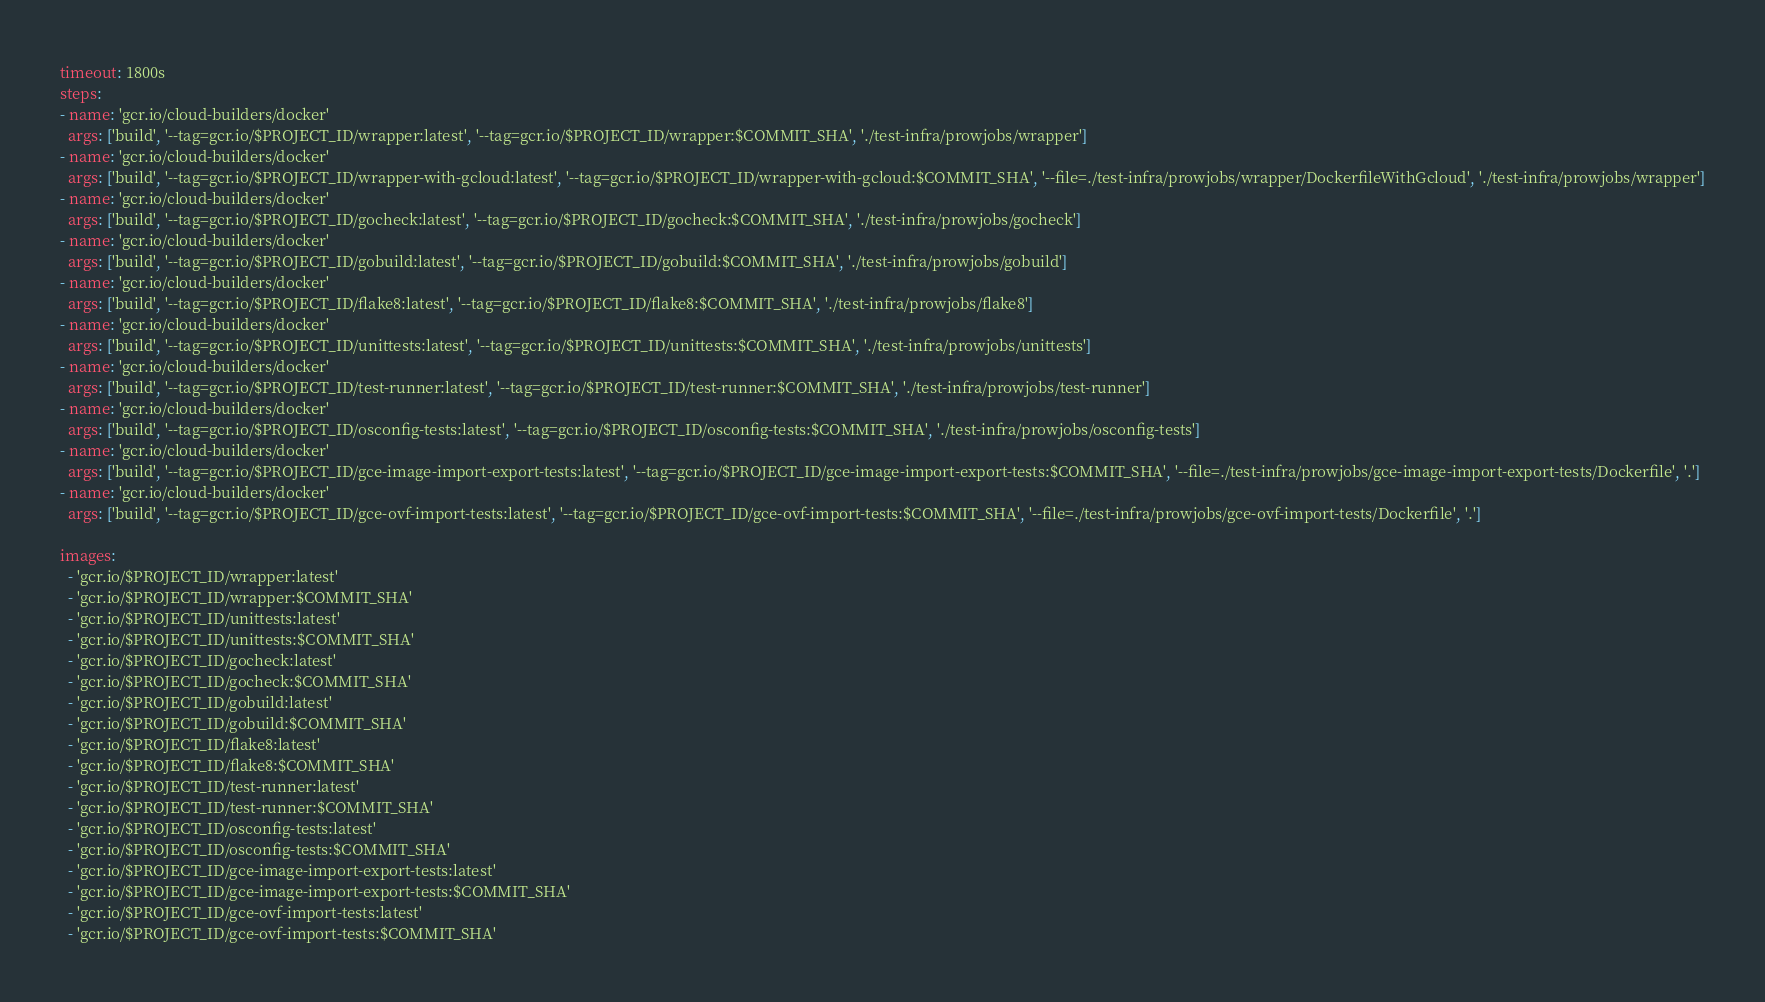Convert code to text. <code><loc_0><loc_0><loc_500><loc_500><_YAML_>timeout: 1800s
steps:
- name: 'gcr.io/cloud-builders/docker'
  args: ['build', '--tag=gcr.io/$PROJECT_ID/wrapper:latest', '--tag=gcr.io/$PROJECT_ID/wrapper:$COMMIT_SHA', './test-infra/prowjobs/wrapper']
- name: 'gcr.io/cloud-builders/docker'
  args: ['build', '--tag=gcr.io/$PROJECT_ID/wrapper-with-gcloud:latest', '--tag=gcr.io/$PROJECT_ID/wrapper-with-gcloud:$COMMIT_SHA', '--file=./test-infra/prowjobs/wrapper/DockerfileWithGcloud', './test-infra/prowjobs/wrapper']
- name: 'gcr.io/cloud-builders/docker'
  args: ['build', '--tag=gcr.io/$PROJECT_ID/gocheck:latest', '--tag=gcr.io/$PROJECT_ID/gocheck:$COMMIT_SHA', './test-infra/prowjobs/gocheck']
- name: 'gcr.io/cloud-builders/docker'
  args: ['build', '--tag=gcr.io/$PROJECT_ID/gobuild:latest', '--tag=gcr.io/$PROJECT_ID/gobuild:$COMMIT_SHA', './test-infra/prowjobs/gobuild']
- name: 'gcr.io/cloud-builders/docker'
  args: ['build', '--tag=gcr.io/$PROJECT_ID/flake8:latest', '--tag=gcr.io/$PROJECT_ID/flake8:$COMMIT_SHA', './test-infra/prowjobs/flake8']
- name: 'gcr.io/cloud-builders/docker'
  args: ['build', '--tag=gcr.io/$PROJECT_ID/unittests:latest', '--tag=gcr.io/$PROJECT_ID/unittests:$COMMIT_SHA', './test-infra/prowjobs/unittests']
- name: 'gcr.io/cloud-builders/docker'
  args: ['build', '--tag=gcr.io/$PROJECT_ID/test-runner:latest', '--tag=gcr.io/$PROJECT_ID/test-runner:$COMMIT_SHA', './test-infra/prowjobs/test-runner']
- name: 'gcr.io/cloud-builders/docker'
  args: ['build', '--tag=gcr.io/$PROJECT_ID/osconfig-tests:latest', '--tag=gcr.io/$PROJECT_ID/osconfig-tests:$COMMIT_SHA', './test-infra/prowjobs/osconfig-tests']
- name: 'gcr.io/cloud-builders/docker'
  args: ['build', '--tag=gcr.io/$PROJECT_ID/gce-image-import-export-tests:latest', '--tag=gcr.io/$PROJECT_ID/gce-image-import-export-tests:$COMMIT_SHA', '--file=./test-infra/prowjobs/gce-image-import-export-tests/Dockerfile', '.']
- name: 'gcr.io/cloud-builders/docker'
  args: ['build', '--tag=gcr.io/$PROJECT_ID/gce-ovf-import-tests:latest', '--tag=gcr.io/$PROJECT_ID/gce-ovf-import-tests:$COMMIT_SHA', '--file=./test-infra/prowjobs/gce-ovf-import-tests/Dockerfile', '.']

images:
  - 'gcr.io/$PROJECT_ID/wrapper:latest'
  - 'gcr.io/$PROJECT_ID/wrapper:$COMMIT_SHA'
  - 'gcr.io/$PROJECT_ID/unittests:latest'
  - 'gcr.io/$PROJECT_ID/unittests:$COMMIT_SHA'
  - 'gcr.io/$PROJECT_ID/gocheck:latest'
  - 'gcr.io/$PROJECT_ID/gocheck:$COMMIT_SHA'
  - 'gcr.io/$PROJECT_ID/gobuild:latest'
  - 'gcr.io/$PROJECT_ID/gobuild:$COMMIT_SHA'
  - 'gcr.io/$PROJECT_ID/flake8:latest'
  - 'gcr.io/$PROJECT_ID/flake8:$COMMIT_SHA'
  - 'gcr.io/$PROJECT_ID/test-runner:latest'
  - 'gcr.io/$PROJECT_ID/test-runner:$COMMIT_SHA'
  - 'gcr.io/$PROJECT_ID/osconfig-tests:latest'
  - 'gcr.io/$PROJECT_ID/osconfig-tests:$COMMIT_SHA'
  - 'gcr.io/$PROJECT_ID/gce-image-import-export-tests:latest'
  - 'gcr.io/$PROJECT_ID/gce-image-import-export-tests:$COMMIT_SHA'
  - 'gcr.io/$PROJECT_ID/gce-ovf-import-tests:latest'
  - 'gcr.io/$PROJECT_ID/gce-ovf-import-tests:$COMMIT_SHA'
</code> 